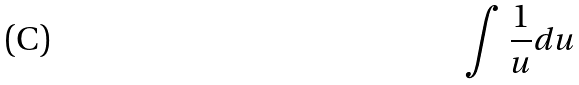<formula> <loc_0><loc_0><loc_500><loc_500>\int \frac { 1 } { u } d u</formula> 